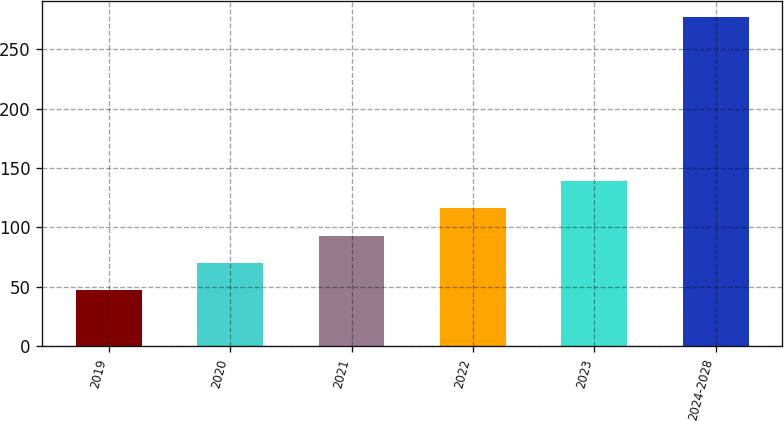Convert chart to OTSL. <chart><loc_0><loc_0><loc_500><loc_500><bar_chart><fcel>2019<fcel>2020<fcel>2021<fcel>2022<fcel>2023<fcel>2024-2028<nl><fcel>47<fcel>70<fcel>93<fcel>116<fcel>139<fcel>277<nl></chart> 